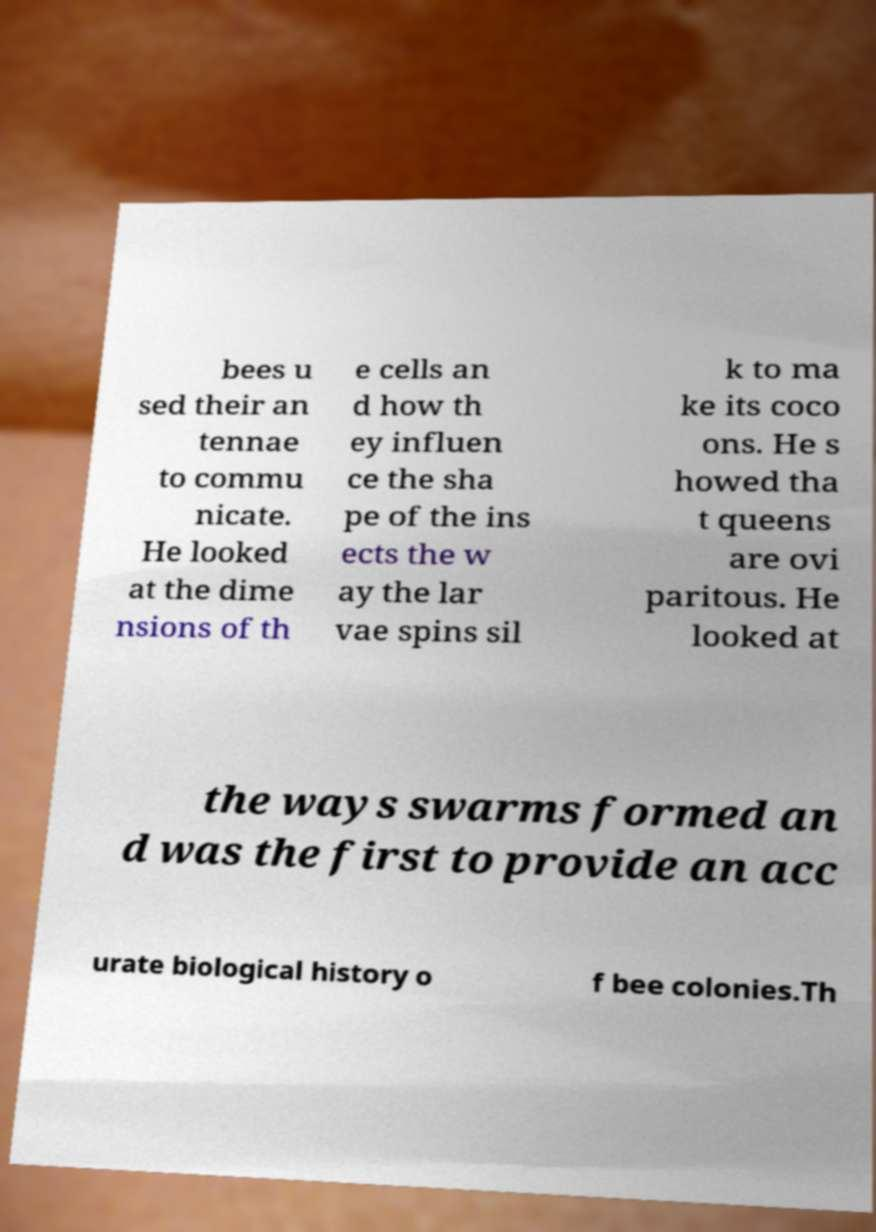Could you extract and type out the text from this image? bees u sed their an tennae to commu nicate. He looked at the dime nsions of th e cells an d how th ey influen ce the sha pe of the ins ects the w ay the lar vae spins sil k to ma ke its coco ons. He s howed tha t queens are ovi paritous. He looked at the ways swarms formed an d was the first to provide an acc urate biological history o f bee colonies.Th 